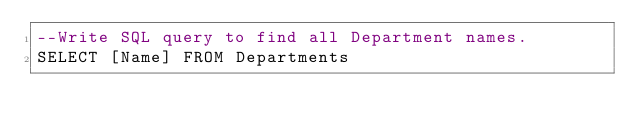Convert code to text. <code><loc_0><loc_0><loc_500><loc_500><_SQL_>--Write SQL query to find all Department names.
SELECT [Name] FROM Departments</code> 